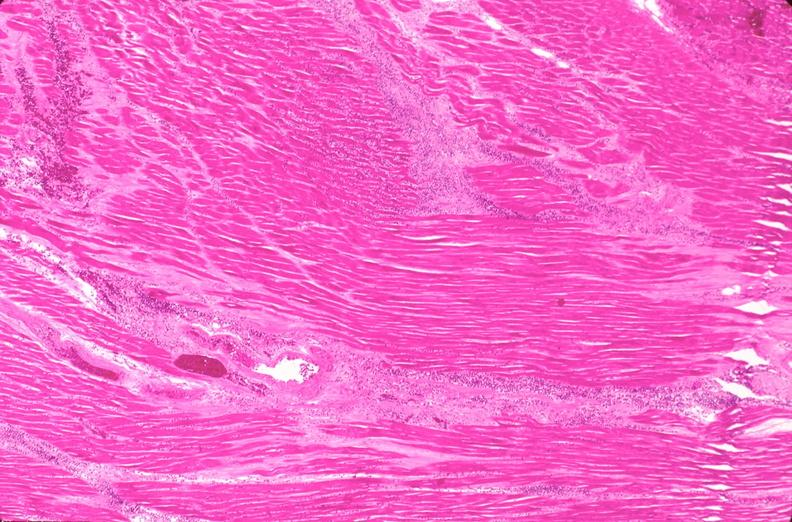s cardiovascular present?
Answer the question using a single word or phrase. Yes 